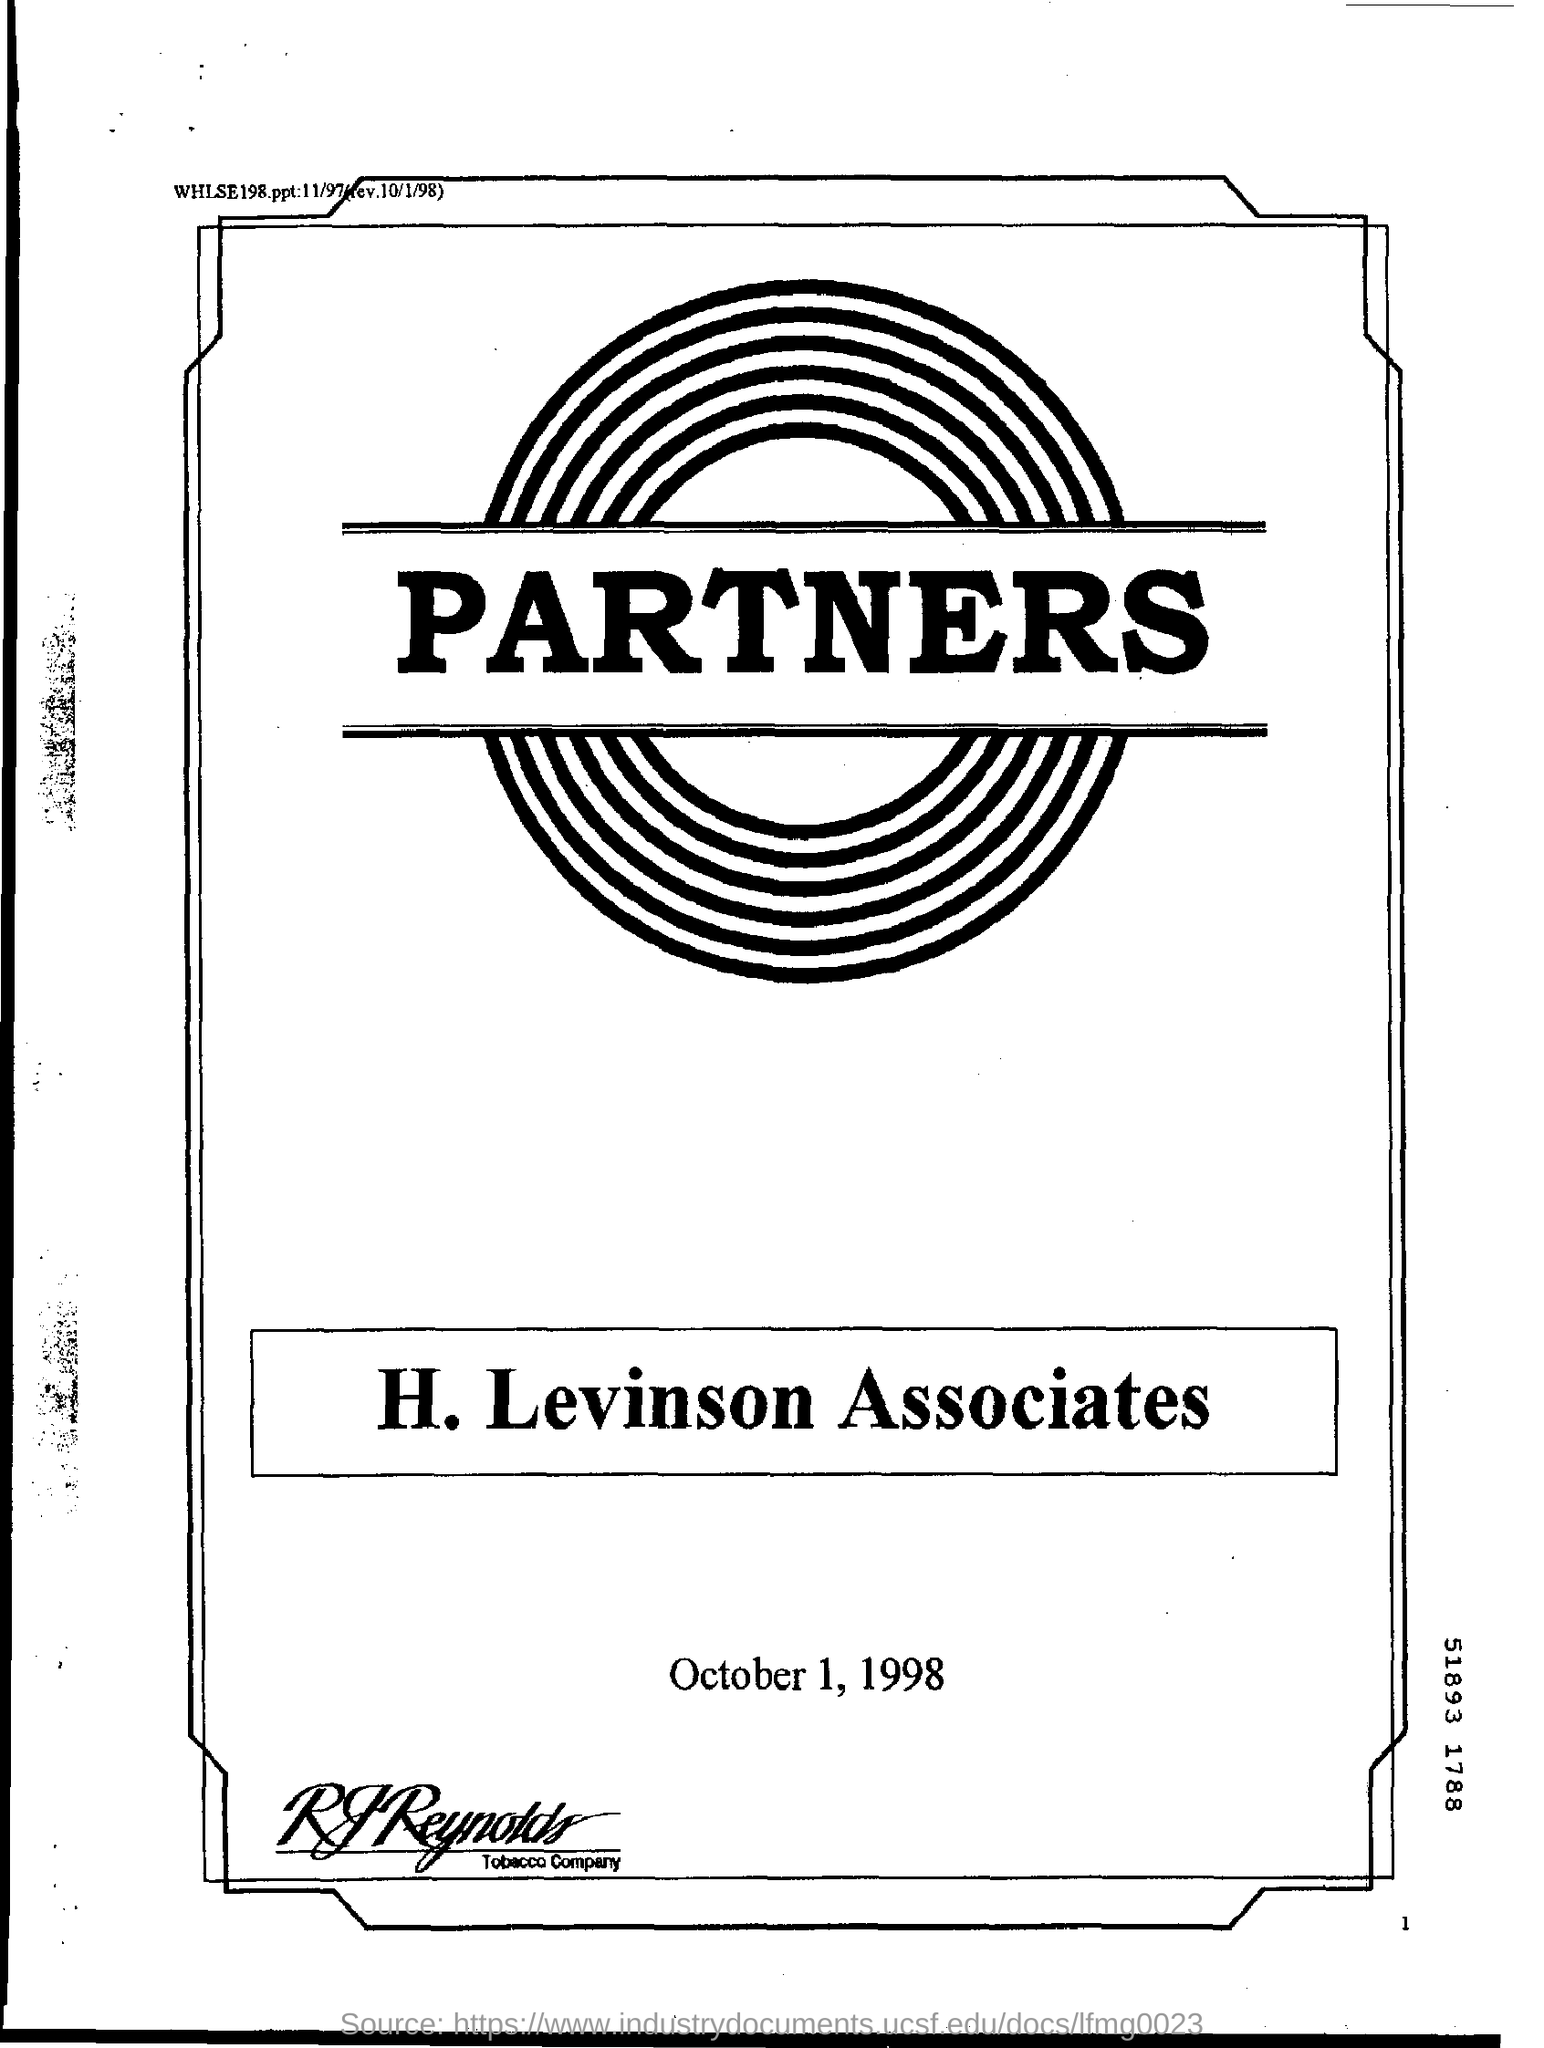Specify some key components in this picture. The name of the Associates is H. Levinson. The date mentioned is October 1, 1998. The name of the company mentioned at the bottom is RJ Reynolds Tobacco Company. The name that appears on the logo is "PARTNERS. 